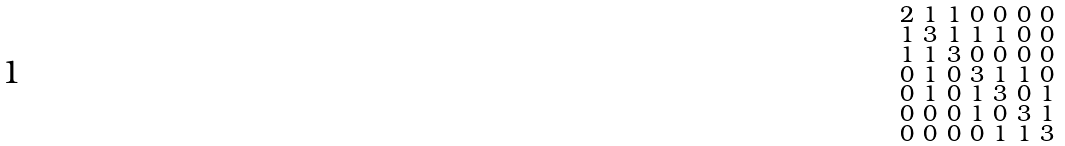<formula> <loc_0><loc_0><loc_500><loc_500>\begin{smallmatrix} 2 & 1 & 1 & 0 & 0 & 0 & 0 \\ 1 & 3 & 1 & 1 & 1 & 0 & 0 \\ 1 & 1 & 3 & 0 & 0 & 0 & 0 \\ 0 & 1 & 0 & 3 & 1 & 1 & 0 \\ 0 & 1 & 0 & 1 & 3 & 0 & 1 \\ 0 & 0 & 0 & 1 & 0 & 3 & 1 \\ 0 & 0 & 0 & 0 & 1 & 1 & 3 \end{smallmatrix}</formula> 